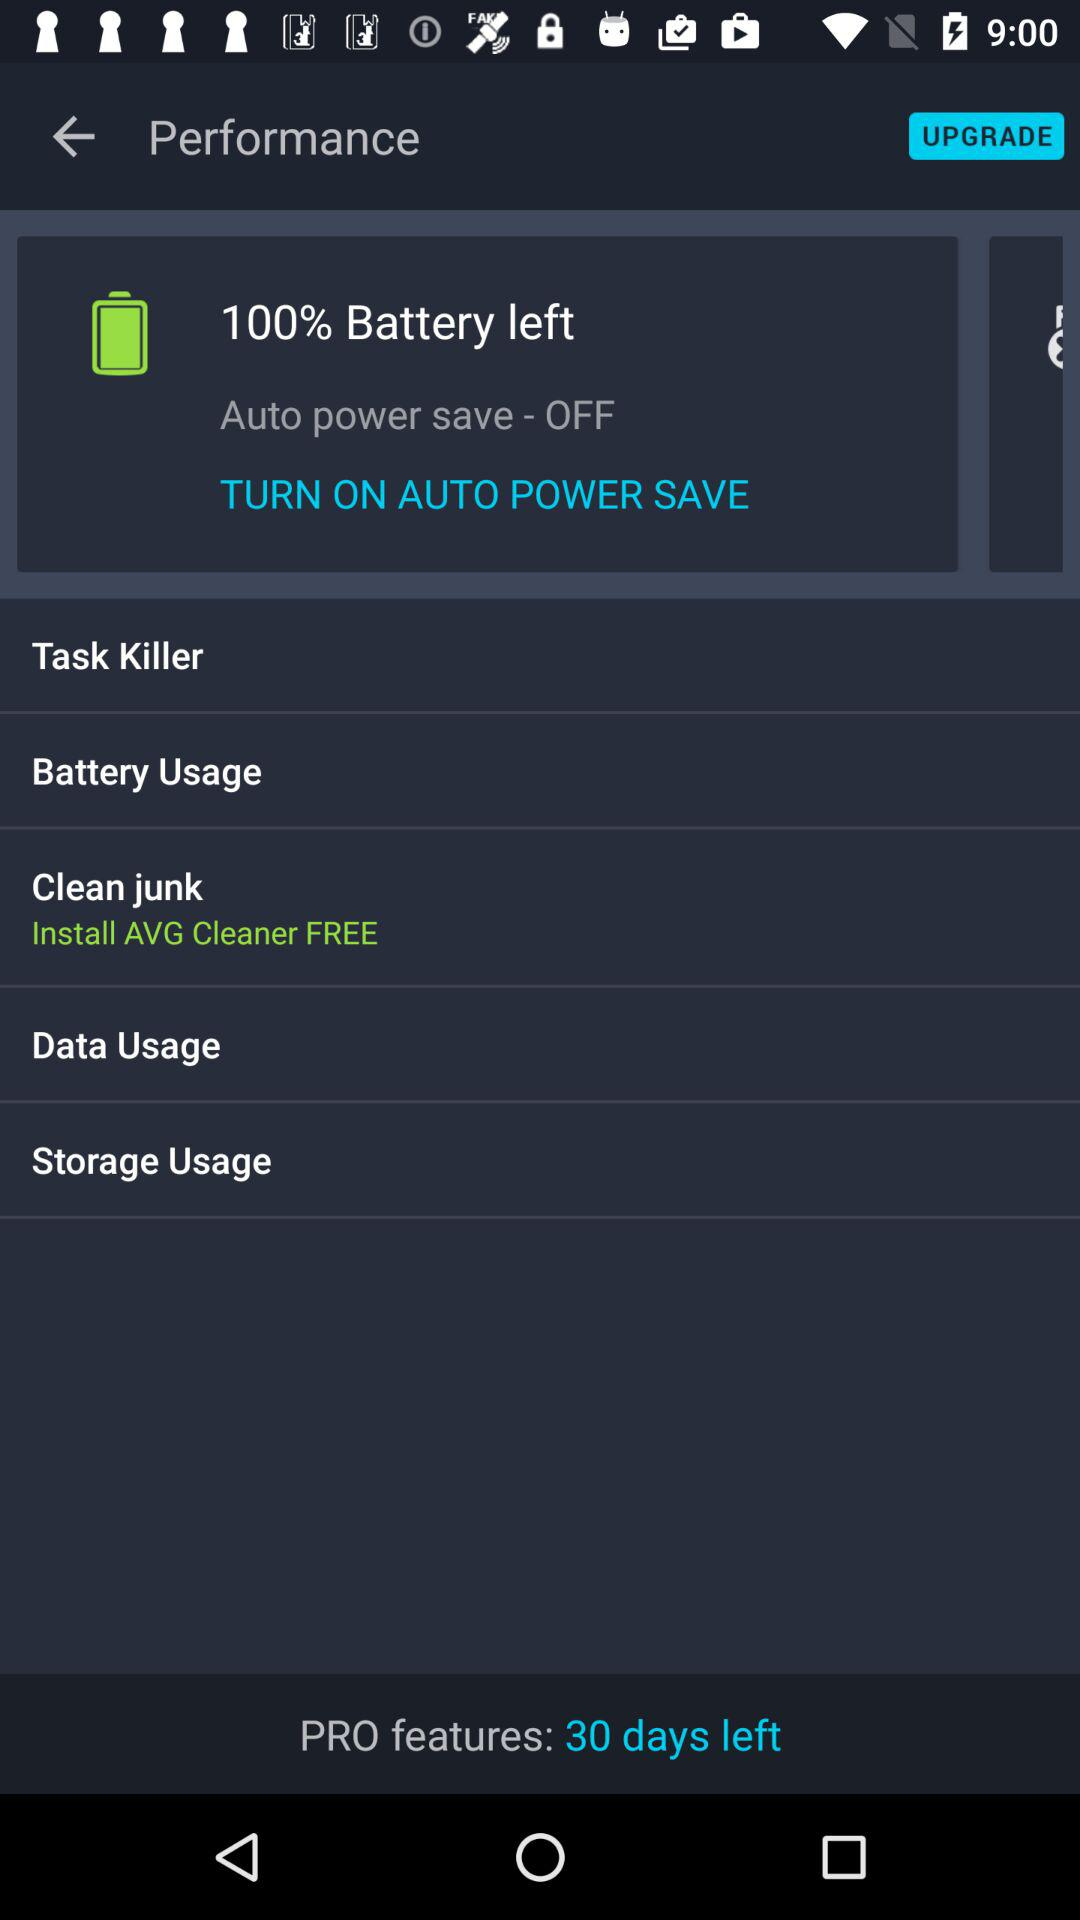What is the percentage of the battery left? The percentage is 100. 